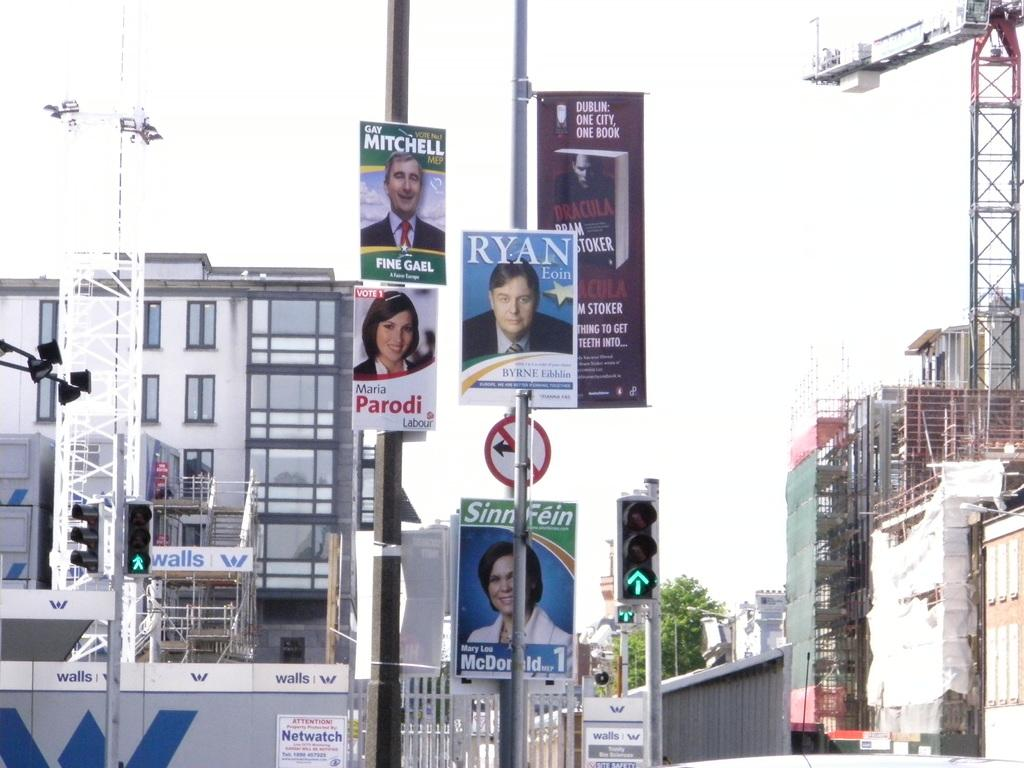<image>
Provide a brief description of the given image. a neighborhood with sings on the poles of Ryan, Parodi and Mitchell. 